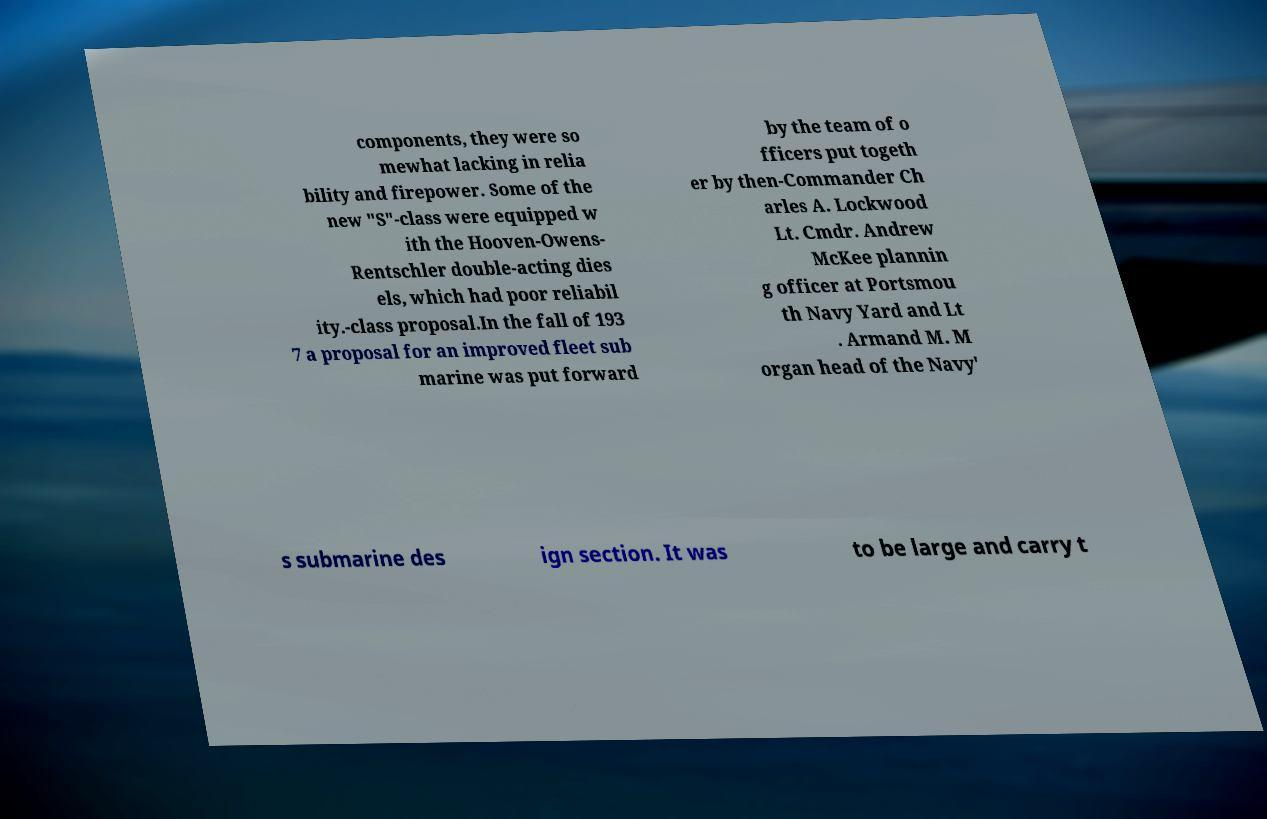For documentation purposes, I need the text within this image transcribed. Could you provide that? components, they were so mewhat lacking in relia bility and firepower. Some of the new "S"-class were equipped w ith the Hooven-Owens- Rentschler double-acting dies els, which had poor reliabil ity.-class proposal.In the fall of 193 7 a proposal for an improved fleet sub marine was put forward by the team of o fficers put togeth er by then-Commander Ch arles A. Lockwood Lt. Cmdr. Andrew McKee plannin g officer at Portsmou th Navy Yard and Lt . Armand M. M organ head of the Navy' s submarine des ign section. It was to be large and carry t 